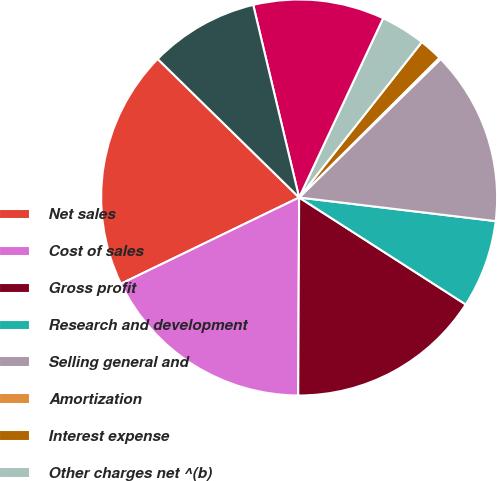Convert chart. <chart><loc_0><loc_0><loc_500><loc_500><pie_chart><fcel>Net sales<fcel>Cost of sales<fcel>Gross profit<fcel>Research and development<fcel>Selling general and<fcel>Amortization<fcel>Interest expense<fcel>Other charges net ^(b)<fcel>Earnings before taxes<fcel>Net earnings<nl><fcel>19.51%<fcel>17.75%<fcel>15.99%<fcel>7.18%<fcel>14.23%<fcel>0.14%<fcel>1.9%<fcel>3.66%<fcel>10.7%<fcel>8.94%<nl></chart> 